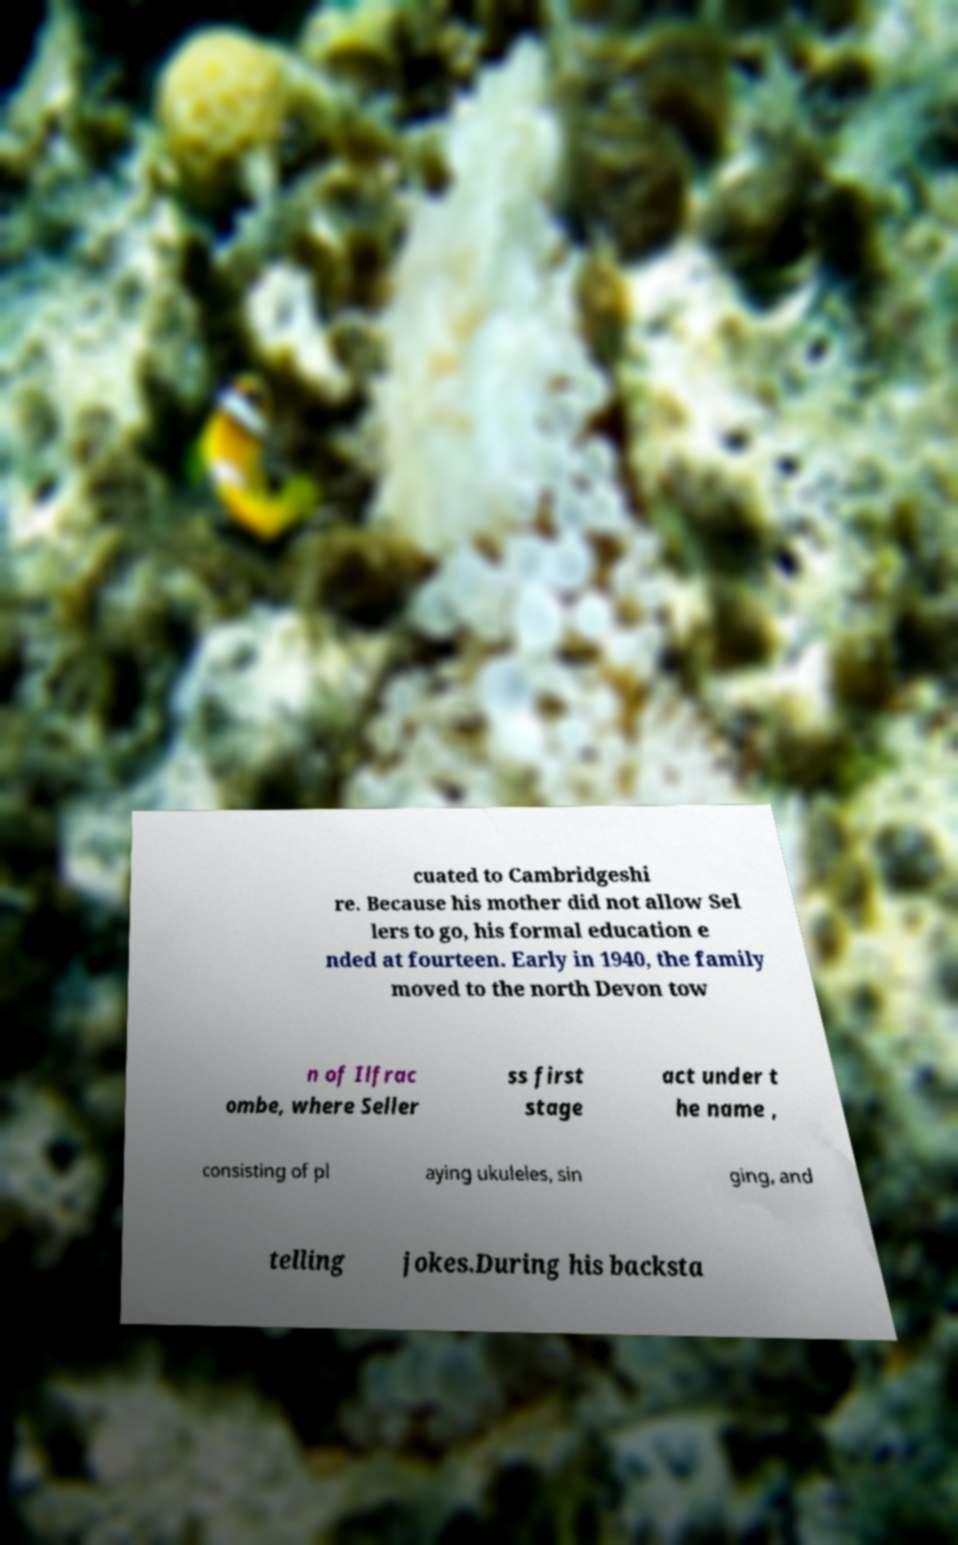Could you extract and type out the text from this image? cuated to Cambridgeshi re. Because his mother did not allow Sel lers to go, his formal education e nded at fourteen. Early in 1940, the family moved to the north Devon tow n of Ilfrac ombe, where Seller ss first stage act under t he name , consisting of pl aying ukuleles, sin ging, and telling jokes.During his backsta 